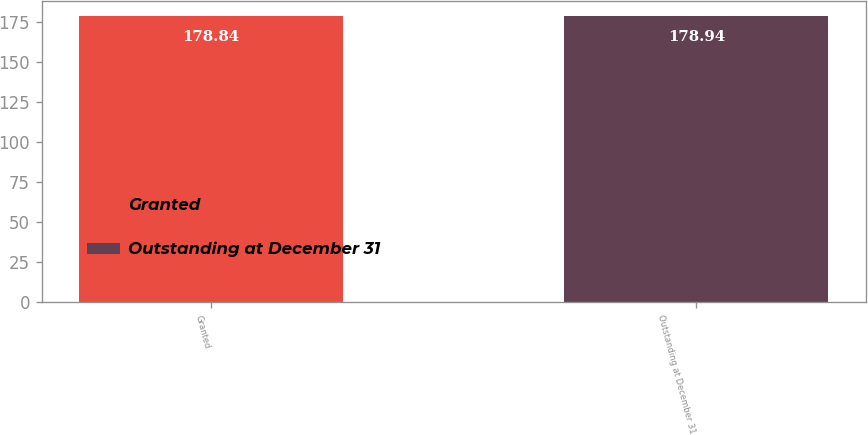Convert chart to OTSL. <chart><loc_0><loc_0><loc_500><loc_500><bar_chart><fcel>Granted<fcel>Outstanding at December 31<nl><fcel>178.84<fcel>178.94<nl></chart> 